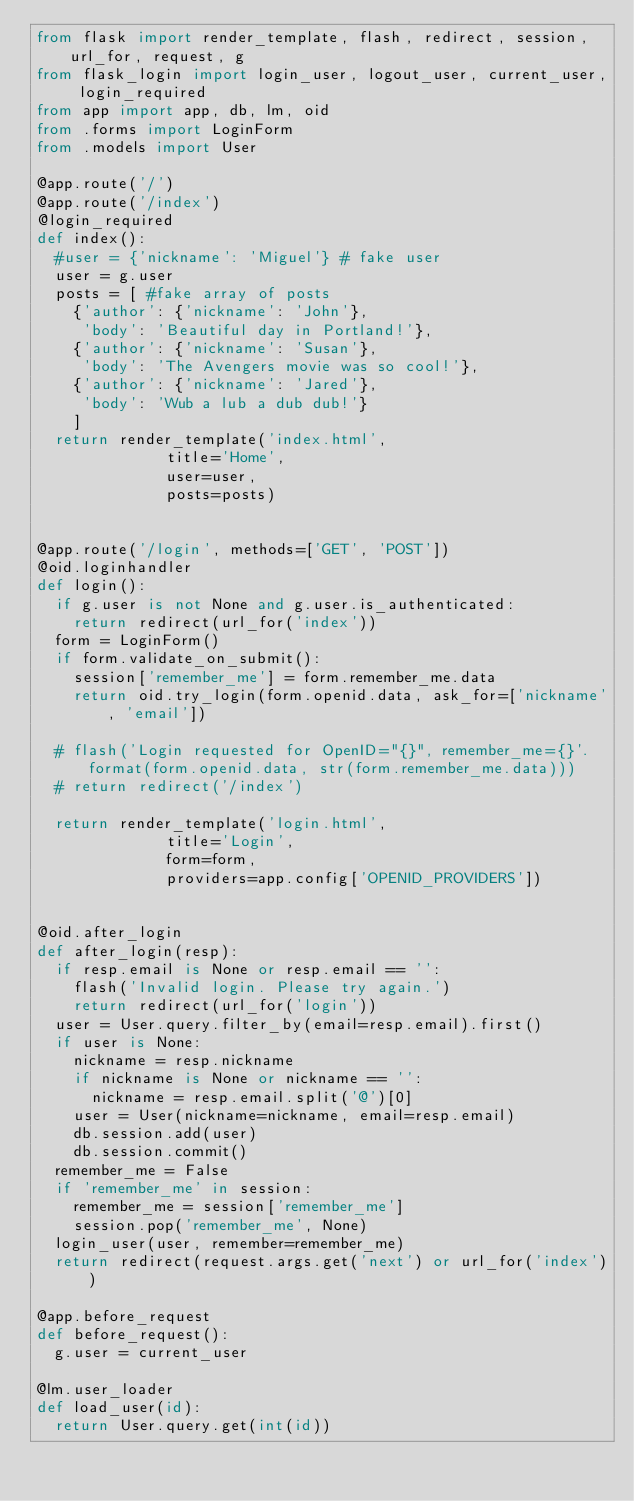<code> <loc_0><loc_0><loc_500><loc_500><_Python_>from flask import render_template, flash, redirect, session, url_for, request, g
from flask_login import login_user, logout_user, current_user, login_required
from app import app, db, lm, oid
from .forms import LoginForm
from .models import User

@app.route('/')
@app.route('/index')
@login_required
def index():
	#user = {'nickname': 'Miguel'} # fake user
	user = g.user
	posts = [ #fake array of posts
		{'author': {'nickname': 'John'},
		 'body': 'Beautiful day in Portland!'},
		{'author': {'nickname': 'Susan'}, 
		 'body': 'The Avengers movie was so cool!'},
		{'author': {'nickname': 'Jared'}, 
		 'body': 'Wub a lub a dub dub!'}
		]
	return render_template('index.html', 
							title='Home', 
							user=user,
							posts=posts)


@app.route('/login', methods=['GET', 'POST'])
@oid.loginhandler
def login():
	if g.user is not None and g.user.is_authenticated:
		return redirect(url_for('index'))
	form = LoginForm()
	if form.validate_on_submit():
		session['remember_me'] = form.remember_me.data
		return oid.try_login(form.openid.data, ask_for=['nickname', 'email'])

	#	flash('Login requested for OpenID="{}", remember_me={}'.format(form.openid.data, str(form.remember_me.data)))
	#	return redirect('/index')

	return render_template('login.html', 
							title='Login',
							form=form,
							providers=app.config['OPENID_PROVIDERS'])


@oid.after_login
def after_login(resp):
	if resp.email is None or resp.email == '':
		flash('Invalid login. Please try again.')
		return redirect(url_for('login'))
	user = User.query.filter_by(email=resp.email).first()
	if user is None:
		nickname = resp.nickname
		if nickname is None or nickname == '':
			nickname = resp.email.split('@')[0]
		user = User(nickname=nickname, email=resp.email)
		db.session.add(user)
		db.session.commit()
	remember_me = False
	if 'remember_me' in session:
		remember_me = session['remember_me']
		session.pop('remember_me', None)
	login_user(user, remember=remember_me)
	return redirect(request.args.get('next') or url_for('index'))

@app.before_request
def before_request():
	g.user = current_user

@lm.user_loader
def load_user(id):
	return User.query.get(int(id))</code> 